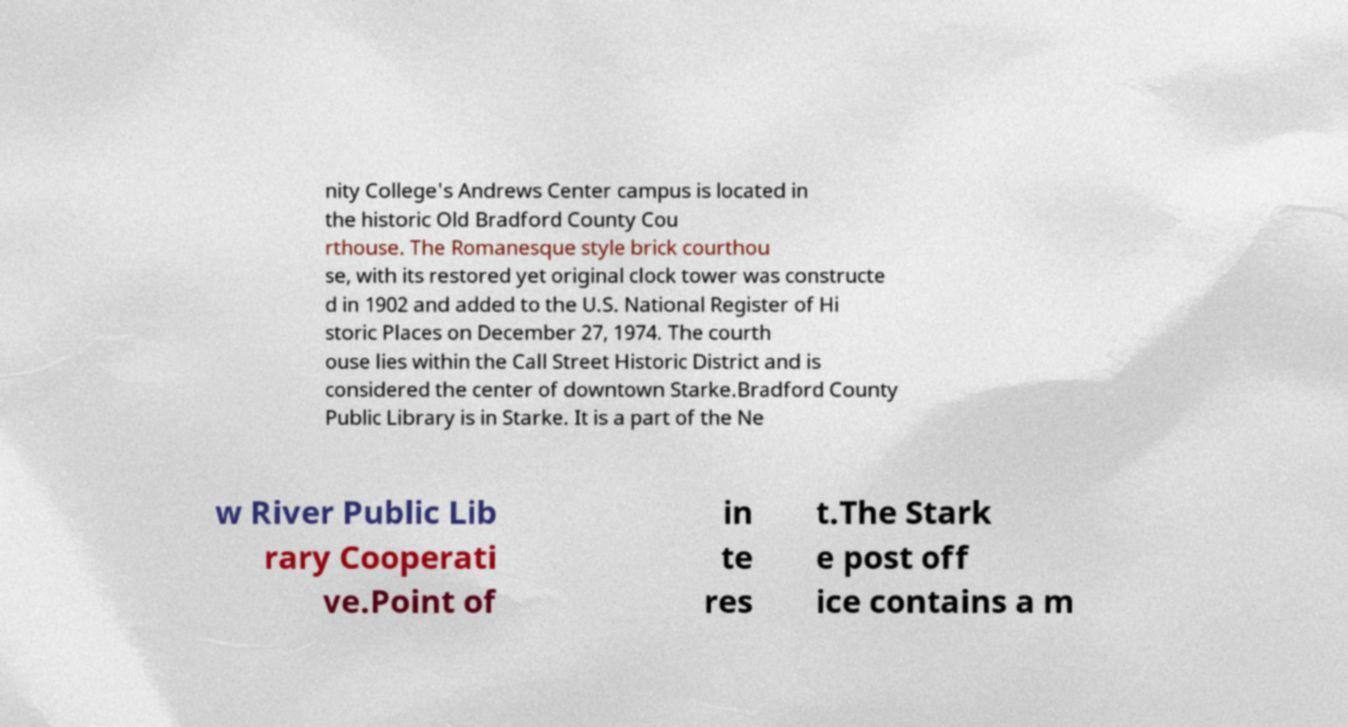For documentation purposes, I need the text within this image transcribed. Could you provide that? nity College's Andrews Center campus is located in the historic Old Bradford County Cou rthouse. The Romanesque style brick courthou se, with its restored yet original clock tower was constructe d in 1902 and added to the U.S. National Register of Hi storic Places on December 27, 1974. The courth ouse lies within the Call Street Historic District and is considered the center of downtown Starke.Bradford County Public Library is in Starke. It is a part of the Ne w River Public Lib rary Cooperati ve.Point of in te res t.The Stark e post off ice contains a m 